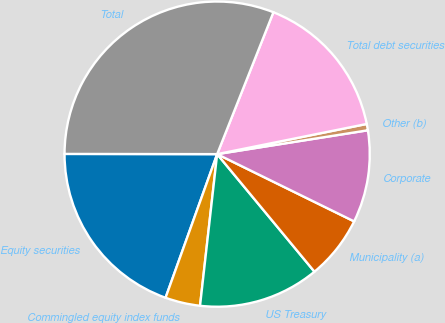Convert chart to OTSL. <chart><loc_0><loc_0><loc_500><loc_500><pie_chart><fcel>Equity securities<fcel>Commingled equity index funds<fcel>US Treasury<fcel>Municipality (a)<fcel>Corporate<fcel>Other (b)<fcel>Total debt securities<fcel>Total<nl><fcel>19.53%<fcel>3.7%<fcel>12.79%<fcel>6.73%<fcel>9.76%<fcel>0.67%<fcel>15.82%<fcel>30.98%<nl></chart> 